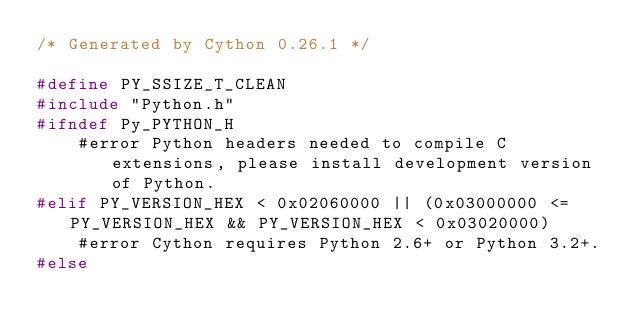<code> <loc_0><loc_0><loc_500><loc_500><_C_>/* Generated by Cython 0.26.1 */

#define PY_SSIZE_T_CLEAN
#include "Python.h"
#ifndef Py_PYTHON_H
    #error Python headers needed to compile C extensions, please install development version of Python.
#elif PY_VERSION_HEX < 0x02060000 || (0x03000000 <= PY_VERSION_HEX && PY_VERSION_HEX < 0x03020000)
    #error Cython requires Python 2.6+ or Python 3.2+.
#else</code> 